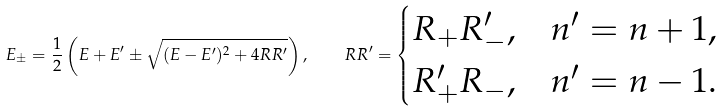<formula> <loc_0><loc_0><loc_500><loc_500>E _ { \pm } = \frac { 1 } { 2 } \left ( E + E ^ { \prime } \pm \sqrt { ( E - E ^ { \prime } ) ^ { 2 } + 4 R R ^ { \prime } } \right ) , \quad R R ^ { \prime } = \begin{cases} R _ { + } R ^ { \prime } _ { - } , & n ^ { \prime } = n + 1 , \\ R ^ { \prime } _ { + } R _ { - } , & n ^ { \prime } = n - 1 . \\ \end{cases}</formula> 